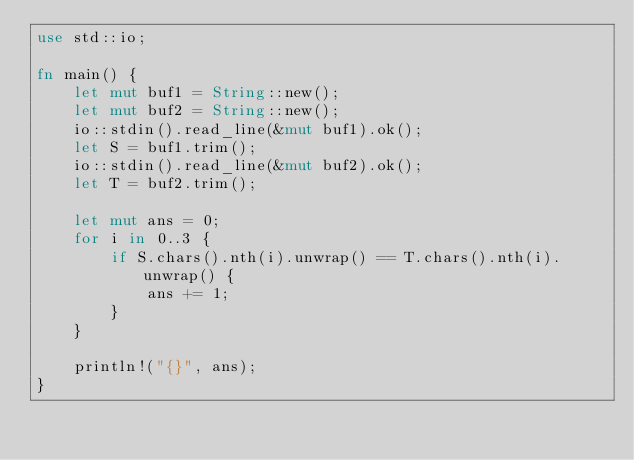<code> <loc_0><loc_0><loc_500><loc_500><_Rust_>use std::io;

fn main() {
    let mut buf1 = String::new();
    let mut buf2 = String::new();
    io::stdin().read_line(&mut buf1).ok();
    let S = buf1.trim();
    io::stdin().read_line(&mut buf2).ok();
    let T = buf2.trim();

    let mut ans = 0;
    for i in 0..3 {
        if S.chars().nth(i).unwrap() == T.chars().nth(i).unwrap() {
            ans += 1;
        }
    }

    println!("{}", ans);
}
</code> 